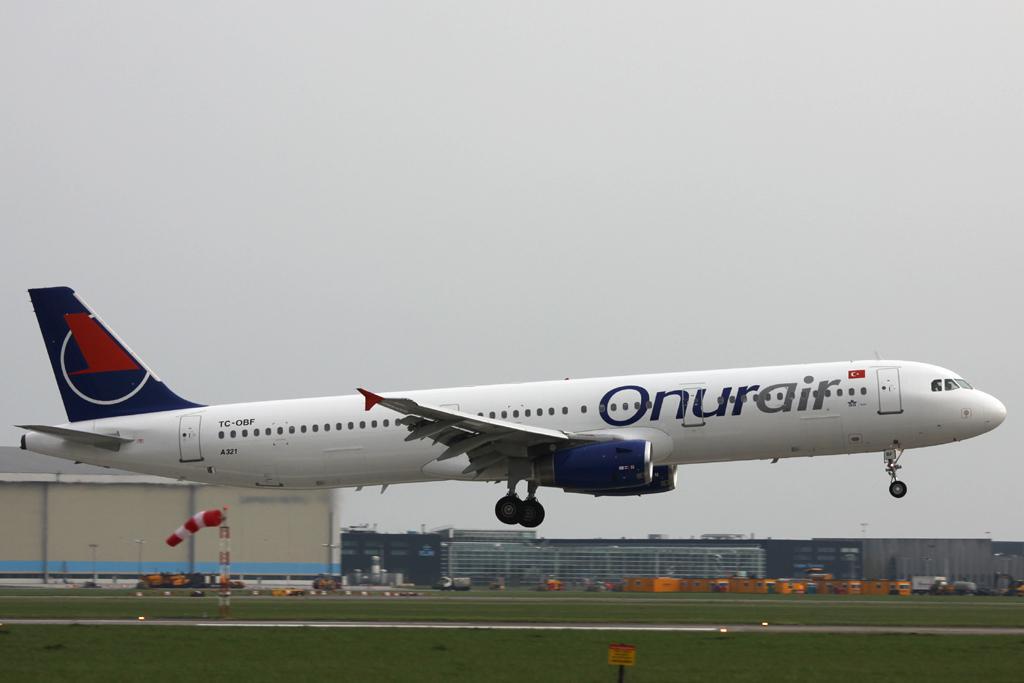What airline is this plane for?
Offer a terse response. Onurair. What is the name of the airline?
Make the answer very short. Onurair. 